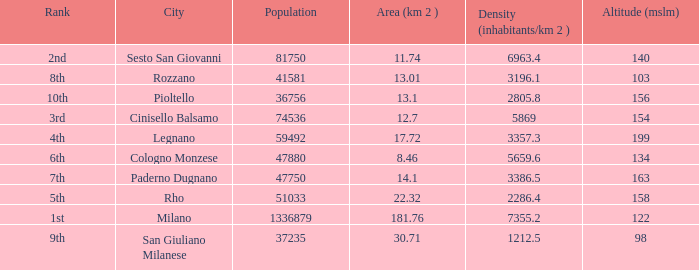Which Altitude (mslm) is the highest one that has an Area (km 2) smaller than 13.01, and a Population of 74536, and a Density (inhabitants/km 2) larger than 5869? None. 